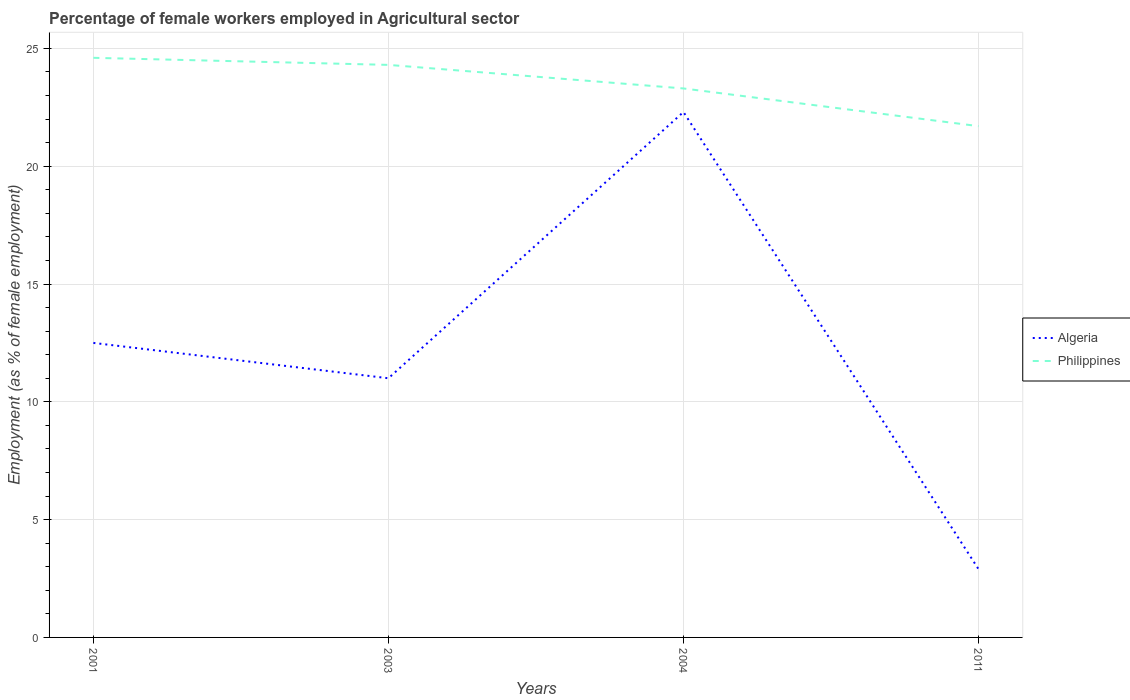How many different coloured lines are there?
Your answer should be very brief. 2. Does the line corresponding to Philippines intersect with the line corresponding to Algeria?
Your answer should be compact. No. Is the number of lines equal to the number of legend labels?
Offer a very short reply. Yes. Across all years, what is the maximum percentage of females employed in Agricultural sector in Philippines?
Give a very brief answer. 21.7. What is the total percentage of females employed in Agricultural sector in Algeria in the graph?
Provide a short and direct response. 19.4. What is the difference between the highest and the second highest percentage of females employed in Agricultural sector in Philippines?
Your answer should be compact. 2.9. What is the difference between the highest and the lowest percentage of females employed in Agricultural sector in Algeria?
Provide a short and direct response. 2. How many lines are there?
Offer a very short reply. 2. What is the difference between two consecutive major ticks on the Y-axis?
Ensure brevity in your answer.  5. Does the graph contain any zero values?
Your response must be concise. No. How many legend labels are there?
Give a very brief answer. 2. How are the legend labels stacked?
Your response must be concise. Vertical. What is the title of the graph?
Offer a terse response. Percentage of female workers employed in Agricultural sector. What is the label or title of the X-axis?
Your response must be concise. Years. What is the label or title of the Y-axis?
Provide a short and direct response. Employment (as % of female employment). What is the Employment (as % of female employment) of Algeria in 2001?
Make the answer very short. 12.5. What is the Employment (as % of female employment) of Philippines in 2001?
Offer a very short reply. 24.6. What is the Employment (as % of female employment) in Algeria in 2003?
Offer a terse response. 11. What is the Employment (as % of female employment) in Philippines in 2003?
Offer a terse response. 24.3. What is the Employment (as % of female employment) in Algeria in 2004?
Ensure brevity in your answer.  22.3. What is the Employment (as % of female employment) of Philippines in 2004?
Provide a succinct answer. 23.3. What is the Employment (as % of female employment) in Algeria in 2011?
Provide a short and direct response. 2.9. What is the Employment (as % of female employment) of Philippines in 2011?
Provide a succinct answer. 21.7. Across all years, what is the maximum Employment (as % of female employment) of Algeria?
Your answer should be compact. 22.3. Across all years, what is the maximum Employment (as % of female employment) in Philippines?
Provide a succinct answer. 24.6. Across all years, what is the minimum Employment (as % of female employment) in Algeria?
Your response must be concise. 2.9. Across all years, what is the minimum Employment (as % of female employment) in Philippines?
Your response must be concise. 21.7. What is the total Employment (as % of female employment) in Algeria in the graph?
Provide a succinct answer. 48.7. What is the total Employment (as % of female employment) of Philippines in the graph?
Your answer should be very brief. 93.9. What is the difference between the Employment (as % of female employment) of Algeria in 2001 and that in 2003?
Ensure brevity in your answer.  1.5. What is the difference between the Employment (as % of female employment) in Philippines in 2001 and that in 2003?
Keep it short and to the point. 0.3. What is the difference between the Employment (as % of female employment) in Algeria in 2001 and that in 2004?
Make the answer very short. -9.8. What is the difference between the Employment (as % of female employment) in Algeria in 2001 and that in 2011?
Offer a very short reply. 9.6. What is the difference between the Employment (as % of female employment) of Algeria in 2003 and that in 2004?
Provide a short and direct response. -11.3. What is the difference between the Employment (as % of female employment) of Philippines in 2003 and that in 2011?
Offer a very short reply. 2.6. What is the difference between the Employment (as % of female employment) of Algeria in 2004 and that in 2011?
Make the answer very short. 19.4. What is the difference between the Employment (as % of female employment) in Philippines in 2004 and that in 2011?
Give a very brief answer. 1.6. What is the difference between the Employment (as % of female employment) of Algeria in 2001 and the Employment (as % of female employment) of Philippines in 2003?
Your answer should be compact. -11.8. What is the difference between the Employment (as % of female employment) of Algeria in 2001 and the Employment (as % of female employment) of Philippines in 2004?
Your answer should be compact. -10.8. What is the difference between the Employment (as % of female employment) of Algeria in 2001 and the Employment (as % of female employment) of Philippines in 2011?
Offer a terse response. -9.2. What is the difference between the Employment (as % of female employment) of Algeria in 2003 and the Employment (as % of female employment) of Philippines in 2004?
Your answer should be very brief. -12.3. What is the difference between the Employment (as % of female employment) in Algeria in 2003 and the Employment (as % of female employment) in Philippines in 2011?
Offer a terse response. -10.7. What is the difference between the Employment (as % of female employment) in Algeria in 2004 and the Employment (as % of female employment) in Philippines in 2011?
Your answer should be very brief. 0.6. What is the average Employment (as % of female employment) of Algeria per year?
Your answer should be very brief. 12.18. What is the average Employment (as % of female employment) in Philippines per year?
Make the answer very short. 23.48. In the year 2001, what is the difference between the Employment (as % of female employment) in Algeria and Employment (as % of female employment) in Philippines?
Make the answer very short. -12.1. In the year 2011, what is the difference between the Employment (as % of female employment) in Algeria and Employment (as % of female employment) in Philippines?
Give a very brief answer. -18.8. What is the ratio of the Employment (as % of female employment) of Algeria in 2001 to that in 2003?
Ensure brevity in your answer.  1.14. What is the ratio of the Employment (as % of female employment) of Philippines in 2001 to that in 2003?
Give a very brief answer. 1.01. What is the ratio of the Employment (as % of female employment) of Algeria in 2001 to that in 2004?
Your response must be concise. 0.56. What is the ratio of the Employment (as % of female employment) of Philippines in 2001 to that in 2004?
Give a very brief answer. 1.06. What is the ratio of the Employment (as % of female employment) of Algeria in 2001 to that in 2011?
Offer a very short reply. 4.31. What is the ratio of the Employment (as % of female employment) in Philippines in 2001 to that in 2011?
Your response must be concise. 1.13. What is the ratio of the Employment (as % of female employment) in Algeria in 2003 to that in 2004?
Your answer should be compact. 0.49. What is the ratio of the Employment (as % of female employment) of Philippines in 2003 to that in 2004?
Give a very brief answer. 1.04. What is the ratio of the Employment (as % of female employment) in Algeria in 2003 to that in 2011?
Keep it short and to the point. 3.79. What is the ratio of the Employment (as % of female employment) in Philippines in 2003 to that in 2011?
Offer a terse response. 1.12. What is the ratio of the Employment (as % of female employment) of Algeria in 2004 to that in 2011?
Make the answer very short. 7.69. What is the ratio of the Employment (as % of female employment) of Philippines in 2004 to that in 2011?
Offer a very short reply. 1.07. What is the difference between the highest and the second highest Employment (as % of female employment) in Philippines?
Your answer should be compact. 0.3. What is the difference between the highest and the lowest Employment (as % of female employment) of Algeria?
Ensure brevity in your answer.  19.4. 